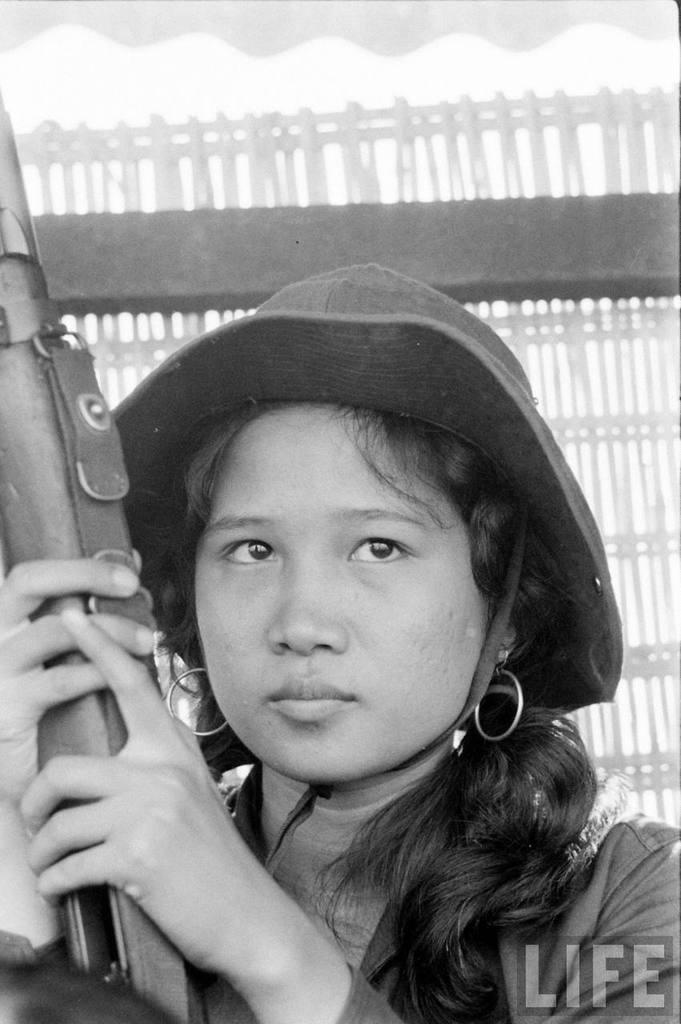Who is the main subject in the image? There is a woman in the image. What is the woman doing in the image? The woman is seated and holding a gun in her hand. What accessory is the woman wearing in the image? The woman is wearing a hat. Is there any additional information about the image itself? Yes, there is a watermark in the bottom right corner of the image. How many ladybugs can be seen on the woman's hat in the image? There are no ladybugs present on the woman's hat in the image. Who is the creator of the watermark in the image? The facts provided do not give information about the creator of the watermark. 